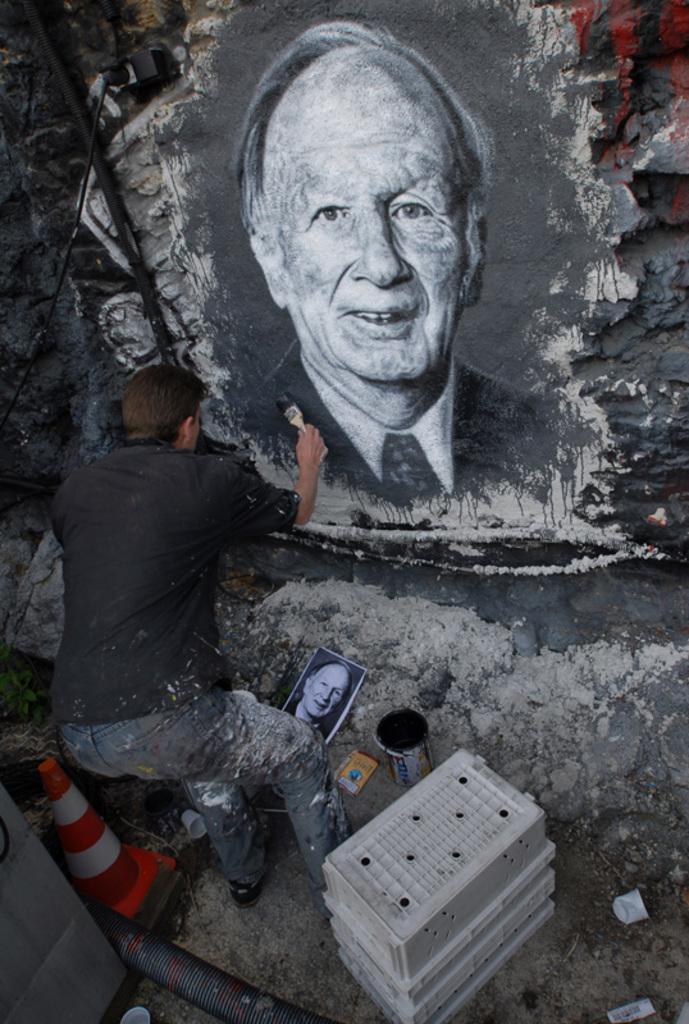Describe this image in one or two sentences. In this picture there is an old man photograph crafted on the rock. Beside there is a man wearing a black t-shirt and painting on the rock. In the front bottom there is a white color boxes and black paint box 